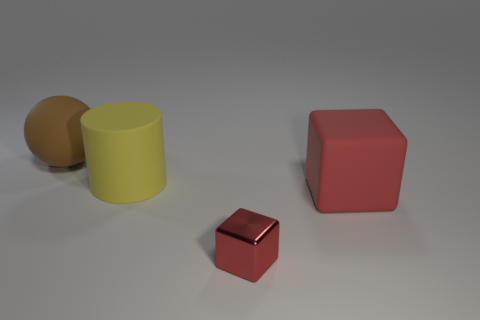What color is the block behind the tiny shiny object?
Give a very brief answer. Red. How many other things are there of the same material as the large brown sphere?
Your response must be concise. 2. Is the number of large yellow objects in front of the tiny red block greater than the number of large rubber cylinders that are in front of the large yellow cylinder?
Provide a succinct answer. No. How many red metallic things are to the right of the large rubber ball?
Make the answer very short. 1. Are the large brown object and the cube that is right of the shiny block made of the same material?
Your answer should be compact. Yes. Is there any other thing that has the same shape as the tiny metallic object?
Give a very brief answer. Yes. Are the small block and the yellow object made of the same material?
Provide a short and direct response. No. There is a matte thing that is to the right of the small metal cube; are there any matte things that are behind it?
Give a very brief answer. Yes. How many things are both behind the red shiny block and to the right of the cylinder?
Offer a very short reply. 1. There is a large object on the left side of the yellow thing; what shape is it?
Your answer should be compact. Sphere. 